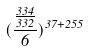<formula> <loc_0><loc_0><loc_500><loc_500>( \frac { \frac { 3 3 4 } { 3 3 2 } } { 6 } ) ^ { 3 7 + 2 5 5 }</formula> 